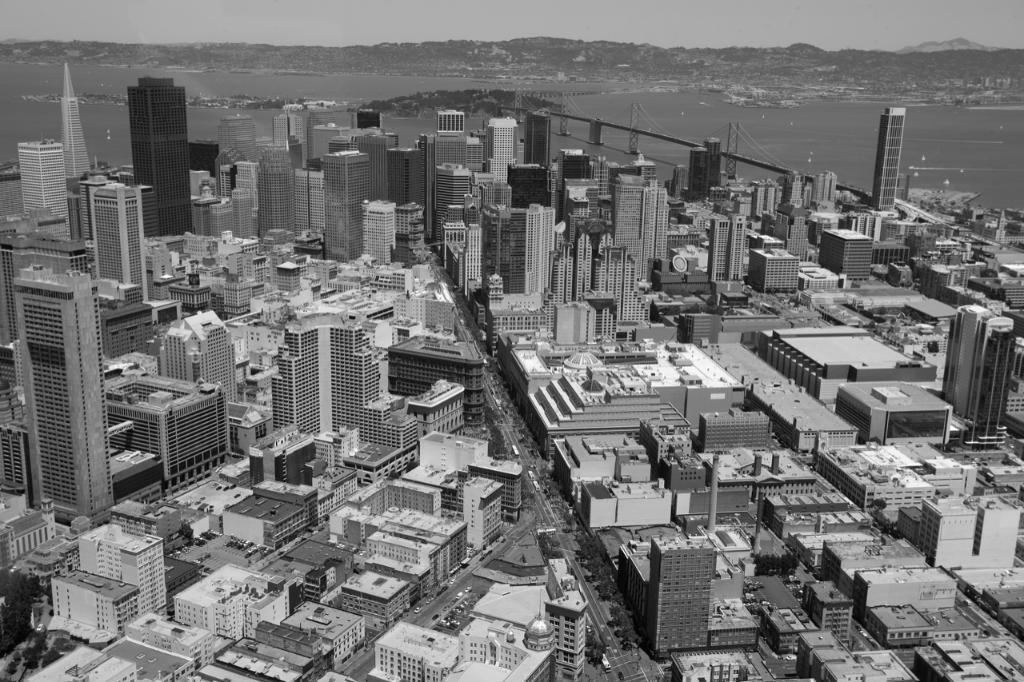What type of structures can be seen in the image? There are many buildings and skyscrapers in the image. What natural feature is present in the image? There is a sea in the image. What part of the sky can be seen in the image? The sky is visible in the image. What type of transportation infrastructure is present in the image? There is a road and a bridge in the image. What type of vegetation is present in the image? There are many trees in the image. How many beans are visible on the bridge in the image? There are no beans present in the image, and therefore no such objects can be observed on the bridge. Is the area in the image known for its quiet atmosphere? The provided facts do not mention anything about the noise level in the area, so it cannot be determined from the image. 